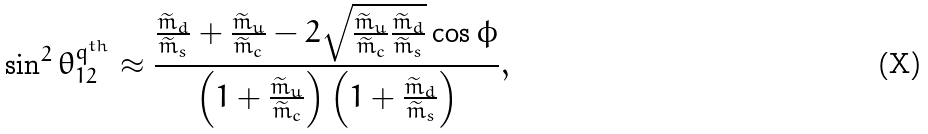Convert formula to latex. <formula><loc_0><loc_0><loc_500><loc_500>\sin ^ { 2 } { \theta _ { 1 2 } ^ { q ^ { t h } } } \approx \frac { \frac { \widetilde { m } _ { d } } { \widetilde { m } _ { s } } + \frac { \widetilde { m } _ { u } } { \widetilde { m } _ { c } } - 2 \sqrt { \frac { \widetilde { m } _ { u } } { \widetilde { m } _ { c } } \frac { \widetilde { m } _ { d } } { \widetilde { m } _ { s } } } \cos { \phi } } { \left ( 1 + \frac { \widetilde { m } _ { u } } { \widetilde { m } _ { c } } \right ) \left ( 1 + \frac { \widetilde { m } _ { d } } { \widetilde { m } _ { s } } \right ) } ,</formula> 